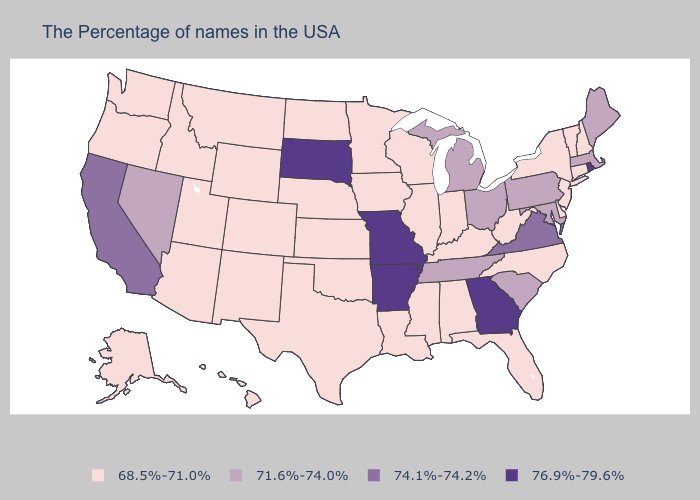Name the states that have a value in the range 74.1%-74.2%?
Quick response, please. Virginia, California. Does Arizona have the lowest value in the West?
Answer briefly. Yes. What is the value of Pennsylvania?
Give a very brief answer. 71.6%-74.0%. What is the lowest value in the MidWest?
Answer briefly. 68.5%-71.0%. Among the states that border Missouri , which have the lowest value?
Give a very brief answer. Kentucky, Illinois, Iowa, Kansas, Nebraska, Oklahoma. Does South Dakota have the highest value in the USA?
Short answer required. Yes. Name the states that have a value in the range 76.9%-79.6%?
Short answer required. Rhode Island, Georgia, Missouri, Arkansas, South Dakota. What is the highest value in the South ?
Be succinct. 76.9%-79.6%. What is the value of South Carolina?
Keep it brief. 71.6%-74.0%. Which states have the lowest value in the USA?
Concise answer only. New Hampshire, Vermont, Connecticut, New York, New Jersey, Delaware, North Carolina, West Virginia, Florida, Kentucky, Indiana, Alabama, Wisconsin, Illinois, Mississippi, Louisiana, Minnesota, Iowa, Kansas, Nebraska, Oklahoma, Texas, North Dakota, Wyoming, Colorado, New Mexico, Utah, Montana, Arizona, Idaho, Washington, Oregon, Alaska, Hawaii. Does Arkansas have the lowest value in the South?
Short answer required. No. What is the highest value in the West ?
Concise answer only. 74.1%-74.2%. How many symbols are there in the legend?
Short answer required. 4. Name the states that have a value in the range 68.5%-71.0%?
Short answer required. New Hampshire, Vermont, Connecticut, New York, New Jersey, Delaware, North Carolina, West Virginia, Florida, Kentucky, Indiana, Alabama, Wisconsin, Illinois, Mississippi, Louisiana, Minnesota, Iowa, Kansas, Nebraska, Oklahoma, Texas, North Dakota, Wyoming, Colorado, New Mexico, Utah, Montana, Arizona, Idaho, Washington, Oregon, Alaska, Hawaii. 